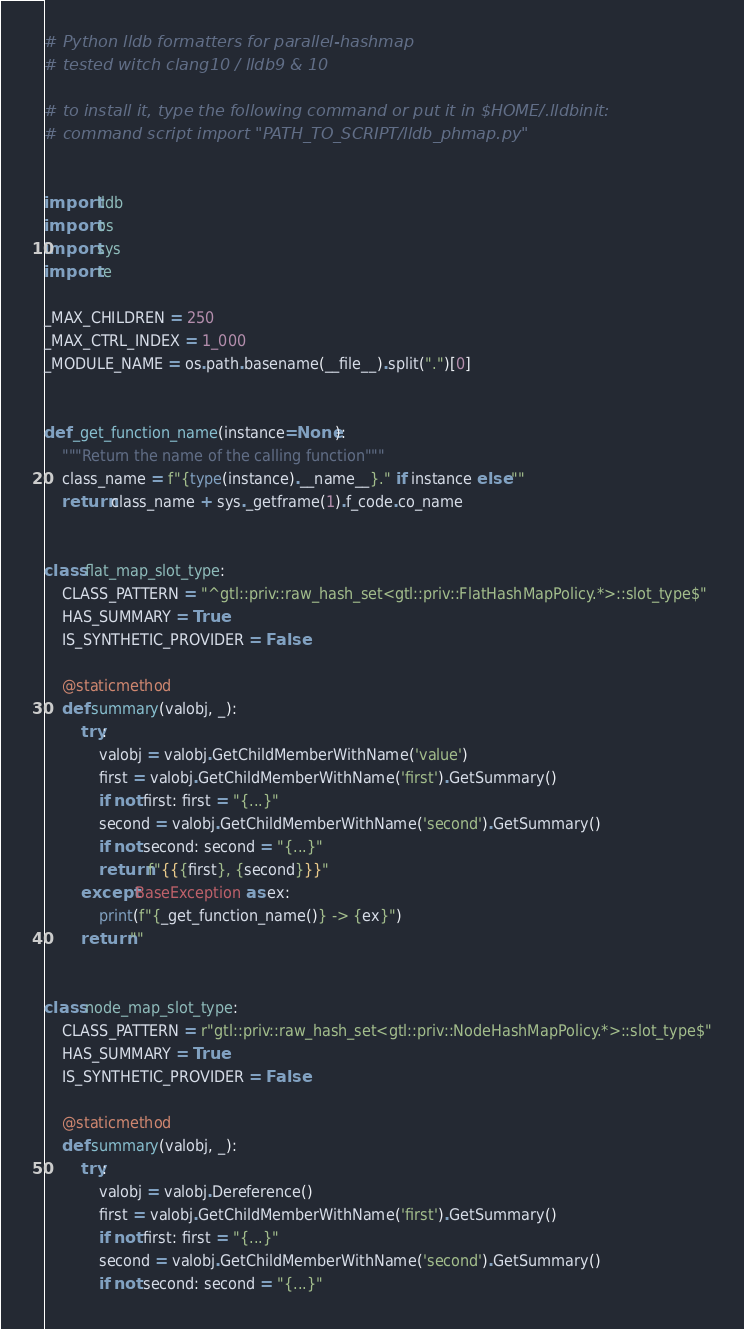Convert code to text. <code><loc_0><loc_0><loc_500><loc_500><_Python_># Python lldb formatters for parallel-hashmap
# tested witch clang10 / lldb9 & 10

# to install it, type the following command or put it in $HOME/.lldbinit:
# command script import "PATH_TO_SCRIPT/lldb_phmap.py"


import lldb
import os
import sys
import re

_MAX_CHILDREN = 250
_MAX_CTRL_INDEX = 1_000
_MODULE_NAME = os.path.basename(__file__).split(".")[0]


def _get_function_name(instance=None):
    """Return the name of the calling function"""
    class_name = f"{type(instance).__name__}." if instance else ""
    return class_name + sys._getframe(1).f_code.co_name


class flat_map_slot_type:
    CLASS_PATTERN = "^gtl::priv::raw_hash_set<gtl::priv::FlatHashMapPolicy.*>::slot_type$"
    HAS_SUMMARY = True
    IS_SYNTHETIC_PROVIDER = False

    @staticmethod
    def summary(valobj, _):
        try:
            valobj = valobj.GetChildMemberWithName('value')
            first = valobj.GetChildMemberWithName('first').GetSummary()
            if not first: first = "{...}"
            second = valobj.GetChildMemberWithName('second').GetSummary()
            if not second: second = "{...}"
            return f"{{{first}, {second}}}"
        except BaseException as ex:
            print(f"{_get_function_name()} -> {ex}")
        return ""


class node_map_slot_type:
    CLASS_PATTERN = r"gtl::priv::raw_hash_set<gtl::priv::NodeHashMapPolicy.*>::slot_type$"
    HAS_SUMMARY = True
    IS_SYNTHETIC_PROVIDER = False

    @staticmethod
    def summary(valobj, _):
        try:
            valobj = valobj.Dereference()
            first = valobj.GetChildMemberWithName('first').GetSummary()
            if not first: first = "{...}"
            second = valobj.GetChildMemberWithName('second').GetSummary()
            if not second: second = "{...}"</code> 